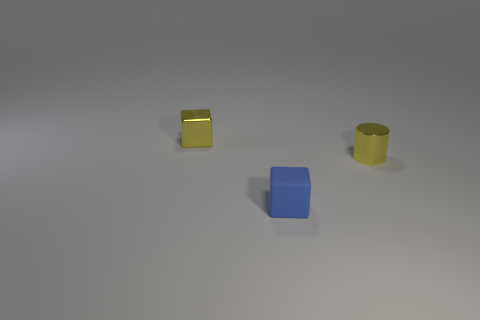Add 2 rubber blocks. How many objects exist? 5 Subtract 1 cubes. How many cubes are left? 1 Subtract all cylinders. How many objects are left? 2 Subtract all big red matte cylinders. Subtract all small yellow cubes. How many objects are left? 2 Add 2 metal cylinders. How many metal cylinders are left? 3 Add 1 tiny yellow metallic things. How many tiny yellow metallic things exist? 3 Subtract 0 purple cylinders. How many objects are left? 3 Subtract all blue cubes. Subtract all yellow spheres. How many cubes are left? 1 